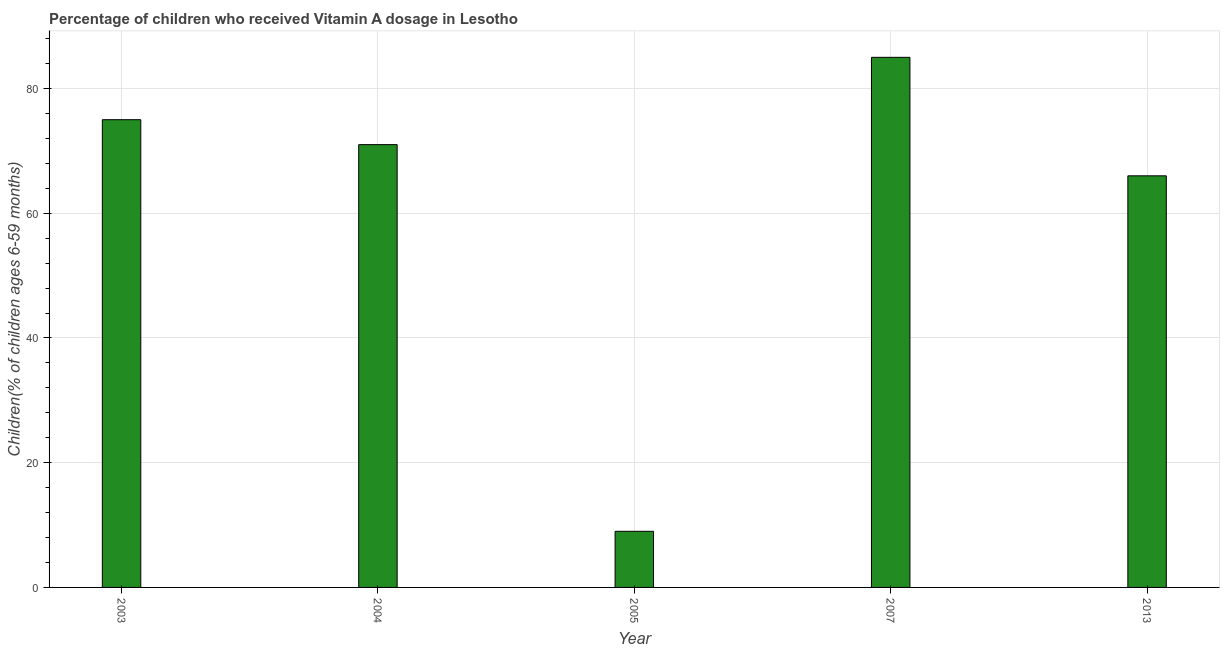Does the graph contain any zero values?
Offer a terse response. No. Does the graph contain grids?
Ensure brevity in your answer.  Yes. What is the title of the graph?
Make the answer very short. Percentage of children who received Vitamin A dosage in Lesotho. What is the label or title of the Y-axis?
Offer a terse response. Children(% of children ages 6-59 months). What is the vitamin a supplementation coverage rate in 2007?
Give a very brief answer. 85. In which year was the vitamin a supplementation coverage rate maximum?
Provide a succinct answer. 2007. In which year was the vitamin a supplementation coverage rate minimum?
Keep it short and to the point. 2005. What is the sum of the vitamin a supplementation coverage rate?
Give a very brief answer. 306. What is the difference between the vitamin a supplementation coverage rate in 2003 and 2007?
Offer a very short reply. -10. What is the average vitamin a supplementation coverage rate per year?
Your answer should be compact. 61. What is the ratio of the vitamin a supplementation coverage rate in 2005 to that in 2007?
Your answer should be compact. 0.11. Is the difference between the vitamin a supplementation coverage rate in 2004 and 2005 greater than the difference between any two years?
Your answer should be compact. No. Is the sum of the vitamin a supplementation coverage rate in 2003 and 2005 greater than the maximum vitamin a supplementation coverage rate across all years?
Provide a succinct answer. No. Are all the bars in the graph horizontal?
Your answer should be compact. No. How many years are there in the graph?
Ensure brevity in your answer.  5. What is the Children(% of children ages 6-59 months) of 2005?
Provide a succinct answer. 9. What is the Children(% of children ages 6-59 months) of 2007?
Your answer should be very brief. 85. What is the Children(% of children ages 6-59 months) in 2013?
Give a very brief answer. 66. What is the difference between the Children(% of children ages 6-59 months) in 2003 and 2007?
Provide a short and direct response. -10. What is the difference between the Children(% of children ages 6-59 months) in 2003 and 2013?
Keep it short and to the point. 9. What is the difference between the Children(% of children ages 6-59 months) in 2004 and 2013?
Offer a very short reply. 5. What is the difference between the Children(% of children ages 6-59 months) in 2005 and 2007?
Offer a very short reply. -76. What is the difference between the Children(% of children ages 6-59 months) in 2005 and 2013?
Ensure brevity in your answer.  -57. What is the difference between the Children(% of children ages 6-59 months) in 2007 and 2013?
Your answer should be compact. 19. What is the ratio of the Children(% of children ages 6-59 months) in 2003 to that in 2004?
Make the answer very short. 1.06. What is the ratio of the Children(% of children ages 6-59 months) in 2003 to that in 2005?
Your answer should be very brief. 8.33. What is the ratio of the Children(% of children ages 6-59 months) in 2003 to that in 2007?
Provide a short and direct response. 0.88. What is the ratio of the Children(% of children ages 6-59 months) in 2003 to that in 2013?
Offer a terse response. 1.14. What is the ratio of the Children(% of children ages 6-59 months) in 2004 to that in 2005?
Make the answer very short. 7.89. What is the ratio of the Children(% of children ages 6-59 months) in 2004 to that in 2007?
Offer a terse response. 0.83. What is the ratio of the Children(% of children ages 6-59 months) in 2004 to that in 2013?
Give a very brief answer. 1.08. What is the ratio of the Children(% of children ages 6-59 months) in 2005 to that in 2007?
Ensure brevity in your answer.  0.11. What is the ratio of the Children(% of children ages 6-59 months) in 2005 to that in 2013?
Offer a very short reply. 0.14. What is the ratio of the Children(% of children ages 6-59 months) in 2007 to that in 2013?
Offer a terse response. 1.29. 